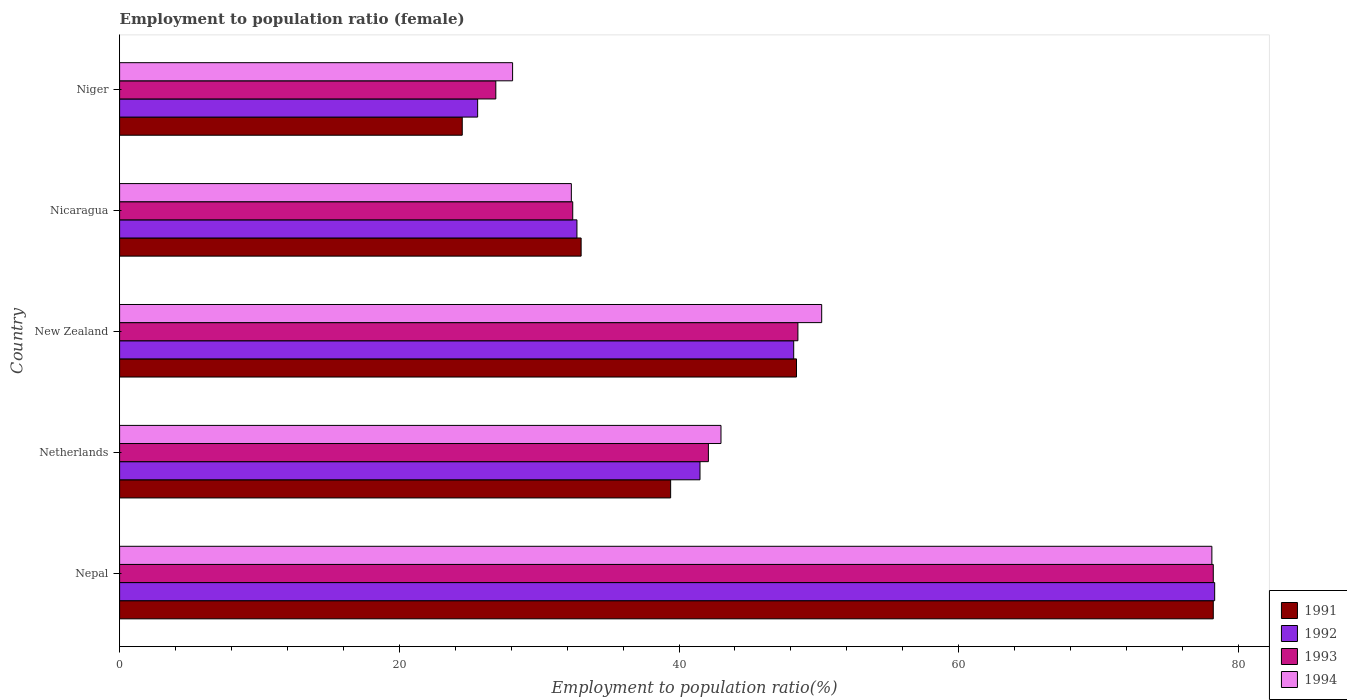How many bars are there on the 1st tick from the bottom?
Your answer should be very brief. 4. What is the label of the 1st group of bars from the top?
Your answer should be very brief. Niger. What is the employment to population ratio in 1993 in Nicaragua?
Your answer should be compact. 32.4. Across all countries, what is the maximum employment to population ratio in 1991?
Your response must be concise. 78.2. Across all countries, what is the minimum employment to population ratio in 1992?
Offer a very short reply. 25.6. In which country was the employment to population ratio in 1992 maximum?
Give a very brief answer. Nepal. In which country was the employment to population ratio in 1993 minimum?
Provide a short and direct response. Niger. What is the total employment to population ratio in 1993 in the graph?
Your answer should be compact. 228.1. What is the difference between the employment to population ratio in 1991 in Nepal and that in Nicaragua?
Offer a terse response. 45.2. What is the difference between the employment to population ratio in 1992 in Niger and the employment to population ratio in 1994 in New Zealand?
Make the answer very short. -24.6. What is the average employment to population ratio in 1991 per country?
Your answer should be very brief. 44.7. What is the ratio of the employment to population ratio in 1994 in Netherlands to that in Niger?
Your answer should be compact. 1.53. Is the difference between the employment to population ratio in 1993 in Netherlands and New Zealand greater than the difference between the employment to population ratio in 1991 in Netherlands and New Zealand?
Your answer should be compact. Yes. What is the difference between the highest and the second highest employment to population ratio in 1993?
Provide a succinct answer. 29.7. What is the difference between the highest and the lowest employment to population ratio in 1994?
Your answer should be very brief. 50. In how many countries, is the employment to population ratio in 1994 greater than the average employment to population ratio in 1994 taken over all countries?
Provide a short and direct response. 2. Is the sum of the employment to population ratio in 1993 in Nepal and Niger greater than the maximum employment to population ratio in 1994 across all countries?
Provide a short and direct response. Yes. What does the 2nd bar from the top in New Zealand represents?
Keep it short and to the point. 1993. What does the 1st bar from the bottom in Niger represents?
Make the answer very short. 1991. Is it the case that in every country, the sum of the employment to population ratio in 1994 and employment to population ratio in 1993 is greater than the employment to population ratio in 1991?
Ensure brevity in your answer.  Yes. How many countries are there in the graph?
Your answer should be very brief. 5. Does the graph contain any zero values?
Make the answer very short. No. What is the title of the graph?
Offer a very short reply. Employment to population ratio (female). Does "1980" appear as one of the legend labels in the graph?
Your answer should be compact. No. What is the label or title of the Y-axis?
Offer a terse response. Country. What is the Employment to population ratio(%) of 1991 in Nepal?
Provide a succinct answer. 78.2. What is the Employment to population ratio(%) of 1992 in Nepal?
Offer a terse response. 78.3. What is the Employment to population ratio(%) in 1993 in Nepal?
Offer a terse response. 78.2. What is the Employment to population ratio(%) of 1994 in Nepal?
Provide a succinct answer. 78.1. What is the Employment to population ratio(%) in 1991 in Netherlands?
Provide a short and direct response. 39.4. What is the Employment to population ratio(%) in 1992 in Netherlands?
Provide a succinct answer. 41.5. What is the Employment to population ratio(%) of 1993 in Netherlands?
Offer a terse response. 42.1. What is the Employment to population ratio(%) in 1991 in New Zealand?
Make the answer very short. 48.4. What is the Employment to population ratio(%) in 1992 in New Zealand?
Keep it short and to the point. 48.2. What is the Employment to population ratio(%) in 1993 in New Zealand?
Your response must be concise. 48.5. What is the Employment to population ratio(%) in 1994 in New Zealand?
Offer a very short reply. 50.2. What is the Employment to population ratio(%) in 1992 in Nicaragua?
Offer a very short reply. 32.7. What is the Employment to population ratio(%) of 1993 in Nicaragua?
Offer a very short reply. 32.4. What is the Employment to population ratio(%) in 1994 in Nicaragua?
Your answer should be compact. 32.3. What is the Employment to population ratio(%) of 1992 in Niger?
Offer a very short reply. 25.6. What is the Employment to population ratio(%) in 1993 in Niger?
Make the answer very short. 26.9. What is the Employment to population ratio(%) in 1994 in Niger?
Ensure brevity in your answer.  28.1. Across all countries, what is the maximum Employment to population ratio(%) of 1991?
Your answer should be compact. 78.2. Across all countries, what is the maximum Employment to population ratio(%) in 1992?
Ensure brevity in your answer.  78.3. Across all countries, what is the maximum Employment to population ratio(%) in 1993?
Your answer should be compact. 78.2. Across all countries, what is the maximum Employment to population ratio(%) in 1994?
Your response must be concise. 78.1. Across all countries, what is the minimum Employment to population ratio(%) in 1991?
Your answer should be very brief. 24.5. Across all countries, what is the minimum Employment to population ratio(%) in 1992?
Your answer should be compact. 25.6. Across all countries, what is the minimum Employment to population ratio(%) of 1993?
Offer a terse response. 26.9. Across all countries, what is the minimum Employment to population ratio(%) of 1994?
Provide a short and direct response. 28.1. What is the total Employment to population ratio(%) of 1991 in the graph?
Give a very brief answer. 223.5. What is the total Employment to population ratio(%) of 1992 in the graph?
Offer a terse response. 226.3. What is the total Employment to population ratio(%) of 1993 in the graph?
Offer a very short reply. 228.1. What is the total Employment to population ratio(%) of 1994 in the graph?
Offer a terse response. 231.7. What is the difference between the Employment to population ratio(%) of 1991 in Nepal and that in Netherlands?
Offer a terse response. 38.8. What is the difference between the Employment to population ratio(%) in 1992 in Nepal and that in Netherlands?
Keep it short and to the point. 36.8. What is the difference between the Employment to population ratio(%) in 1993 in Nepal and that in Netherlands?
Your answer should be compact. 36.1. What is the difference between the Employment to population ratio(%) of 1994 in Nepal and that in Netherlands?
Ensure brevity in your answer.  35.1. What is the difference between the Employment to population ratio(%) in 1991 in Nepal and that in New Zealand?
Your response must be concise. 29.8. What is the difference between the Employment to population ratio(%) in 1992 in Nepal and that in New Zealand?
Provide a succinct answer. 30.1. What is the difference between the Employment to population ratio(%) in 1993 in Nepal and that in New Zealand?
Offer a very short reply. 29.7. What is the difference between the Employment to population ratio(%) of 1994 in Nepal and that in New Zealand?
Provide a succinct answer. 27.9. What is the difference between the Employment to population ratio(%) in 1991 in Nepal and that in Nicaragua?
Provide a short and direct response. 45.2. What is the difference between the Employment to population ratio(%) in 1992 in Nepal and that in Nicaragua?
Provide a short and direct response. 45.6. What is the difference between the Employment to population ratio(%) in 1993 in Nepal and that in Nicaragua?
Your answer should be very brief. 45.8. What is the difference between the Employment to population ratio(%) of 1994 in Nepal and that in Nicaragua?
Provide a short and direct response. 45.8. What is the difference between the Employment to population ratio(%) of 1991 in Nepal and that in Niger?
Ensure brevity in your answer.  53.7. What is the difference between the Employment to population ratio(%) in 1992 in Nepal and that in Niger?
Provide a short and direct response. 52.7. What is the difference between the Employment to population ratio(%) in 1993 in Nepal and that in Niger?
Your answer should be compact. 51.3. What is the difference between the Employment to population ratio(%) in 1994 in Nepal and that in Niger?
Your response must be concise. 50. What is the difference between the Employment to population ratio(%) in 1993 in Netherlands and that in New Zealand?
Keep it short and to the point. -6.4. What is the difference between the Employment to population ratio(%) in 1994 in Netherlands and that in New Zealand?
Offer a terse response. -7.2. What is the difference between the Employment to population ratio(%) in 1991 in Netherlands and that in Nicaragua?
Offer a terse response. 6.4. What is the difference between the Employment to population ratio(%) in 1992 in Netherlands and that in Nicaragua?
Ensure brevity in your answer.  8.8. What is the difference between the Employment to population ratio(%) in 1991 in Netherlands and that in Niger?
Offer a terse response. 14.9. What is the difference between the Employment to population ratio(%) of 1993 in Netherlands and that in Niger?
Offer a terse response. 15.2. What is the difference between the Employment to population ratio(%) in 1994 in Netherlands and that in Niger?
Make the answer very short. 14.9. What is the difference between the Employment to population ratio(%) of 1993 in New Zealand and that in Nicaragua?
Give a very brief answer. 16.1. What is the difference between the Employment to population ratio(%) in 1994 in New Zealand and that in Nicaragua?
Provide a succinct answer. 17.9. What is the difference between the Employment to population ratio(%) of 1991 in New Zealand and that in Niger?
Give a very brief answer. 23.9. What is the difference between the Employment to population ratio(%) in 1992 in New Zealand and that in Niger?
Make the answer very short. 22.6. What is the difference between the Employment to population ratio(%) in 1993 in New Zealand and that in Niger?
Keep it short and to the point. 21.6. What is the difference between the Employment to population ratio(%) of 1994 in New Zealand and that in Niger?
Give a very brief answer. 22.1. What is the difference between the Employment to population ratio(%) in 1992 in Nicaragua and that in Niger?
Your answer should be very brief. 7.1. What is the difference between the Employment to population ratio(%) of 1993 in Nicaragua and that in Niger?
Offer a very short reply. 5.5. What is the difference between the Employment to population ratio(%) in 1994 in Nicaragua and that in Niger?
Provide a succinct answer. 4.2. What is the difference between the Employment to population ratio(%) in 1991 in Nepal and the Employment to population ratio(%) in 1992 in Netherlands?
Provide a short and direct response. 36.7. What is the difference between the Employment to population ratio(%) of 1991 in Nepal and the Employment to population ratio(%) of 1993 in Netherlands?
Give a very brief answer. 36.1. What is the difference between the Employment to population ratio(%) in 1991 in Nepal and the Employment to population ratio(%) in 1994 in Netherlands?
Offer a very short reply. 35.2. What is the difference between the Employment to population ratio(%) of 1992 in Nepal and the Employment to population ratio(%) of 1993 in Netherlands?
Your response must be concise. 36.2. What is the difference between the Employment to population ratio(%) of 1992 in Nepal and the Employment to population ratio(%) of 1994 in Netherlands?
Make the answer very short. 35.3. What is the difference between the Employment to population ratio(%) of 1993 in Nepal and the Employment to population ratio(%) of 1994 in Netherlands?
Provide a short and direct response. 35.2. What is the difference between the Employment to population ratio(%) in 1991 in Nepal and the Employment to population ratio(%) in 1993 in New Zealand?
Give a very brief answer. 29.7. What is the difference between the Employment to population ratio(%) of 1992 in Nepal and the Employment to population ratio(%) of 1993 in New Zealand?
Make the answer very short. 29.8. What is the difference between the Employment to population ratio(%) in 1992 in Nepal and the Employment to population ratio(%) in 1994 in New Zealand?
Offer a very short reply. 28.1. What is the difference between the Employment to population ratio(%) of 1993 in Nepal and the Employment to population ratio(%) of 1994 in New Zealand?
Ensure brevity in your answer.  28. What is the difference between the Employment to population ratio(%) in 1991 in Nepal and the Employment to population ratio(%) in 1992 in Nicaragua?
Keep it short and to the point. 45.5. What is the difference between the Employment to population ratio(%) in 1991 in Nepal and the Employment to population ratio(%) in 1993 in Nicaragua?
Offer a terse response. 45.8. What is the difference between the Employment to population ratio(%) of 1991 in Nepal and the Employment to population ratio(%) of 1994 in Nicaragua?
Offer a terse response. 45.9. What is the difference between the Employment to population ratio(%) of 1992 in Nepal and the Employment to population ratio(%) of 1993 in Nicaragua?
Keep it short and to the point. 45.9. What is the difference between the Employment to population ratio(%) in 1992 in Nepal and the Employment to population ratio(%) in 1994 in Nicaragua?
Offer a terse response. 46. What is the difference between the Employment to population ratio(%) in 1993 in Nepal and the Employment to population ratio(%) in 1994 in Nicaragua?
Make the answer very short. 45.9. What is the difference between the Employment to population ratio(%) of 1991 in Nepal and the Employment to population ratio(%) of 1992 in Niger?
Give a very brief answer. 52.6. What is the difference between the Employment to population ratio(%) in 1991 in Nepal and the Employment to population ratio(%) in 1993 in Niger?
Your answer should be very brief. 51.3. What is the difference between the Employment to population ratio(%) of 1991 in Nepal and the Employment to population ratio(%) of 1994 in Niger?
Keep it short and to the point. 50.1. What is the difference between the Employment to population ratio(%) of 1992 in Nepal and the Employment to population ratio(%) of 1993 in Niger?
Ensure brevity in your answer.  51.4. What is the difference between the Employment to population ratio(%) in 1992 in Nepal and the Employment to population ratio(%) in 1994 in Niger?
Your response must be concise. 50.2. What is the difference between the Employment to population ratio(%) in 1993 in Nepal and the Employment to population ratio(%) in 1994 in Niger?
Give a very brief answer. 50.1. What is the difference between the Employment to population ratio(%) in 1991 in Netherlands and the Employment to population ratio(%) in 1992 in New Zealand?
Keep it short and to the point. -8.8. What is the difference between the Employment to population ratio(%) in 1991 in Netherlands and the Employment to population ratio(%) in 1993 in New Zealand?
Your answer should be compact. -9.1. What is the difference between the Employment to population ratio(%) of 1991 in Netherlands and the Employment to population ratio(%) of 1994 in Nicaragua?
Your answer should be very brief. 7.1. What is the difference between the Employment to population ratio(%) in 1992 in Netherlands and the Employment to population ratio(%) in 1993 in Nicaragua?
Offer a very short reply. 9.1. What is the difference between the Employment to population ratio(%) in 1992 in Netherlands and the Employment to population ratio(%) in 1994 in Nicaragua?
Your answer should be compact. 9.2. What is the difference between the Employment to population ratio(%) of 1993 in Netherlands and the Employment to population ratio(%) of 1994 in Nicaragua?
Give a very brief answer. 9.8. What is the difference between the Employment to population ratio(%) of 1991 in Netherlands and the Employment to population ratio(%) of 1992 in Niger?
Ensure brevity in your answer.  13.8. What is the difference between the Employment to population ratio(%) of 1991 in Netherlands and the Employment to population ratio(%) of 1993 in Niger?
Give a very brief answer. 12.5. What is the difference between the Employment to population ratio(%) in 1992 in New Zealand and the Employment to population ratio(%) in 1993 in Nicaragua?
Offer a terse response. 15.8. What is the difference between the Employment to population ratio(%) of 1993 in New Zealand and the Employment to population ratio(%) of 1994 in Nicaragua?
Your answer should be very brief. 16.2. What is the difference between the Employment to population ratio(%) of 1991 in New Zealand and the Employment to population ratio(%) of 1992 in Niger?
Your answer should be very brief. 22.8. What is the difference between the Employment to population ratio(%) in 1991 in New Zealand and the Employment to population ratio(%) in 1993 in Niger?
Offer a very short reply. 21.5. What is the difference between the Employment to population ratio(%) in 1991 in New Zealand and the Employment to population ratio(%) in 1994 in Niger?
Offer a terse response. 20.3. What is the difference between the Employment to population ratio(%) in 1992 in New Zealand and the Employment to population ratio(%) in 1993 in Niger?
Your answer should be very brief. 21.3. What is the difference between the Employment to population ratio(%) in 1992 in New Zealand and the Employment to population ratio(%) in 1994 in Niger?
Provide a succinct answer. 20.1. What is the difference between the Employment to population ratio(%) in 1993 in New Zealand and the Employment to population ratio(%) in 1994 in Niger?
Your answer should be compact. 20.4. What is the difference between the Employment to population ratio(%) of 1991 in Nicaragua and the Employment to population ratio(%) of 1993 in Niger?
Keep it short and to the point. 6.1. What is the difference between the Employment to population ratio(%) of 1993 in Nicaragua and the Employment to population ratio(%) of 1994 in Niger?
Offer a terse response. 4.3. What is the average Employment to population ratio(%) in 1991 per country?
Your response must be concise. 44.7. What is the average Employment to population ratio(%) of 1992 per country?
Keep it short and to the point. 45.26. What is the average Employment to population ratio(%) in 1993 per country?
Make the answer very short. 45.62. What is the average Employment to population ratio(%) in 1994 per country?
Ensure brevity in your answer.  46.34. What is the difference between the Employment to population ratio(%) in 1991 and Employment to population ratio(%) in 1992 in Nepal?
Provide a succinct answer. -0.1. What is the difference between the Employment to population ratio(%) in 1991 and Employment to population ratio(%) in 1994 in Nepal?
Make the answer very short. 0.1. What is the difference between the Employment to population ratio(%) of 1992 and Employment to population ratio(%) of 1994 in Nepal?
Offer a terse response. 0.2. What is the difference between the Employment to population ratio(%) in 1991 and Employment to population ratio(%) in 1992 in Netherlands?
Provide a succinct answer. -2.1. What is the difference between the Employment to population ratio(%) in 1992 and Employment to population ratio(%) in 1994 in Netherlands?
Give a very brief answer. -1.5. What is the difference between the Employment to population ratio(%) of 1993 and Employment to population ratio(%) of 1994 in Netherlands?
Provide a succinct answer. -0.9. What is the difference between the Employment to population ratio(%) in 1991 and Employment to population ratio(%) in 1992 in New Zealand?
Offer a terse response. 0.2. What is the difference between the Employment to population ratio(%) in 1991 and Employment to population ratio(%) in 1993 in New Zealand?
Your response must be concise. -0.1. What is the difference between the Employment to population ratio(%) of 1991 and Employment to population ratio(%) of 1994 in New Zealand?
Ensure brevity in your answer.  -1.8. What is the difference between the Employment to population ratio(%) of 1992 and Employment to population ratio(%) of 1993 in New Zealand?
Ensure brevity in your answer.  -0.3. What is the difference between the Employment to population ratio(%) in 1991 and Employment to population ratio(%) in 1992 in Nicaragua?
Offer a terse response. 0.3. What is the difference between the Employment to population ratio(%) in 1991 and Employment to population ratio(%) in 1993 in Nicaragua?
Provide a short and direct response. 0.6. What is the difference between the Employment to population ratio(%) of 1992 and Employment to population ratio(%) of 1994 in Nicaragua?
Your answer should be very brief. 0.4. What is the difference between the Employment to population ratio(%) of 1991 and Employment to population ratio(%) of 1992 in Niger?
Offer a terse response. -1.1. What is the difference between the Employment to population ratio(%) in 1991 and Employment to population ratio(%) in 1994 in Niger?
Your answer should be compact. -3.6. What is the difference between the Employment to population ratio(%) in 1992 and Employment to population ratio(%) in 1993 in Niger?
Offer a very short reply. -1.3. What is the difference between the Employment to population ratio(%) in 1993 and Employment to population ratio(%) in 1994 in Niger?
Keep it short and to the point. -1.2. What is the ratio of the Employment to population ratio(%) of 1991 in Nepal to that in Netherlands?
Offer a terse response. 1.98. What is the ratio of the Employment to population ratio(%) in 1992 in Nepal to that in Netherlands?
Make the answer very short. 1.89. What is the ratio of the Employment to population ratio(%) of 1993 in Nepal to that in Netherlands?
Your response must be concise. 1.86. What is the ratio of the Employment to population ratio(%) of 1994 in Nepal to that in Netherlands?
Your answer should be very brief. 1.82. What is the ratio of the Employment to population ratio(%) of 1991 in Nepal to that in New Zealand?
Your answer should be compact. 1.62. What is the ratio of the Employment to population ratio(%) of 1992 in Nepal to that in New Zealand?
Your response must be concise. 1.62. What is the ratio of the Employment to population ratio(%) in 1993 in Nepal to that in New Zealand?
Your answer should be very brief. 1.61. What is the ratio of the Employment to population ratio(%) in 1994 in Nepal to that in New Zealand?
Keep it short and to the point. 1.56. What is the ratio of the Employment to population ratio(%) in 1991 in Nepal to that in Nicaragua?
Your answer should be very brief. 2.37. What is the ratio of the Employment to population ratio(%) of 1992 in Nepal to that in Nicaragua?
Offer a terse response. 2.39. What is the ratio of the Employment to population ratio(%) of 1993 in Nepal to that in Nicaragua?
Offer a terse response. 2.41. What is the ratio of the Employment to population ratio(%) of 1994 in Nepal to that in Nicaragua?
Your answer should be very brief. 2.42. What is the ratio of the Employment to population ratio(%) of 1991 in Nepal to that in Niger?
Your response must be concise. 3.19. What is the ratio of the Employment to population ratio(%) in 1992 in Nepal to that in Niger?
Give a very brief answer. 3.06. What is the ratio of the Employment to population ratio(%) of 1993 in Nepal to that in Niger?
Offer a terse response. 2.91. What is the ratio of the Employment to population ratio(%) in 1994 in Nepal to that in Niger?
Keep it short and to the point. 2.78. What is the ratio of the Employment to population ratio(%) in 1991 in Netherlands to that in New Zealand?
Offer a terse response. 0.81. What is the ratio of the Employment to population ratio(%) of 1992 in Netherlands to that in New Zealand?
Give a very brief answer. 0.86. What is the ratio of the Employment to population ratio(%) of 1993 in Netherlands to that in New Zealand?
Keep it short and to the point. 0.87. What is the ratio of the Employment to population ratio(%) in 1994 in Netherlands to that in New Zealand?
Offer a very short reply. 0.86. What is the ratio of the Employment to population ratio(%) of 1991 in Netherlands to that in Nicaragua?
Provide a short and direct response. 1.19. What is the ratio of the Employment to population ratio(%) of 1992 in Netherlands to that in Nicaragua?
Provide a succinct answer. 1.27. What is the ratio of the Employment to population ratio(%) of 1993 in Netherlands to that in Nicaragua?
Ensure brevity in your answer.  1.3. What is the ratio of the Employment to population ratio(%) in 1994 in Netherlands to that in Nicaragua?
Offer a terse response. 1.33. What is the ratio of the Employment to population ratio(%) of 1991 in Netherlands to that in Niger?
Your answer should be very brief. 1.61. What is the ratio of the Employment to population ratio(%) in 1992 in Netherlands to that in Niger?
Give a very brief answer. 1.62. What is the ratio of the Employment to population ratio(%) in 1993 in Netherlands to that in Niger?
Your answer should be very brief. 1.57. What is the ratio of the Employment to population ratio(%) in 1994 in Netherlands to that in Niger?
Give a very brief answer. 1.53. What is the ratio of the Employment to population ratio(%) of 1991 in New Zealand to that in Nicaragua?
Ensure brevity in your answer.  1.47. What is the ratio of the Employment to population ratio(%) of 1992 in New Zealand to that in Nicaragua?
Your response must be concise. 1.47. What is the ratio of the Employment to population ratio(%) in 1993 in New Zealand to that in Nicaragua?
Make the answer very short. 1.5. What is the ratio of the Employment to population ratio(%) in 1994 in New Zealand to that in Nicaragua?
Keep it short and to the point. 1.55. What is the ratio of the Employment to population ratio(%) of 1991 in New Zealand to that in Niger?
Provide a short and direct response. 1.98. What is the ratio of the Employment to population ratio(%) of 1992 in New Zealand to that in Niger?
Keep it short and to the point. 1.88. What is the ratio of the Employment to population ratio(%) of 1993 in New Zealand to that in Niger?
Your answer should be very brief. 1.8. What is the ratio of the Employment to population ratio(%) of 1994 in New Zealand to that in Niger?
Provide a short and direct response. 1.79. What is the ratio of the Employment to population ratio(%) in 1991 in Nicaragua to that in Niger?
Offer a very short reply. 1.35. What is the ratio of the Employment to population ratio(%) of 1992 in Nicaragua to that in Niger?
Make the answer very short. 1.28. What is the ratio of the Employment to population ratio(%) in 1993 in Nicaragua to that in Niger?
Provide a succinct answer. 1.2. What is the ratio of the Employment to population ratio(%) of 1994 in Nicaragua to that in Niger?
Make the answer very short. 1.15. What is the difference between the highest and the second highest Employment to population ratio(%) of 1991?
Offer a very short reply. 29.8. What is the difference between the highest and the second highest Employment to population ratio(%) of 1992?
Keep it short and to the point. 30.1. What is the difference between the highest and the second highest Employment to population ratio(%) of 1993?
Your answer should be compact. 29.7. What is the difference between the highest and the second highest Employment to population ratio(%) of 1994?
Ensure brevity in your answer.  27.9. What is the difference between the highest and the lowest Employment to population ratio(%) in 1991?
Give a very brief answer. 53.7. What is the difference between the highest and the lowest Employment to population ratio(%) in 1992?
Your answer should be compact. 52.7. What is the difference between the highest and the lowest Employment to population ratio(%) of 1993?
Offer a very short reply. 51.3. 